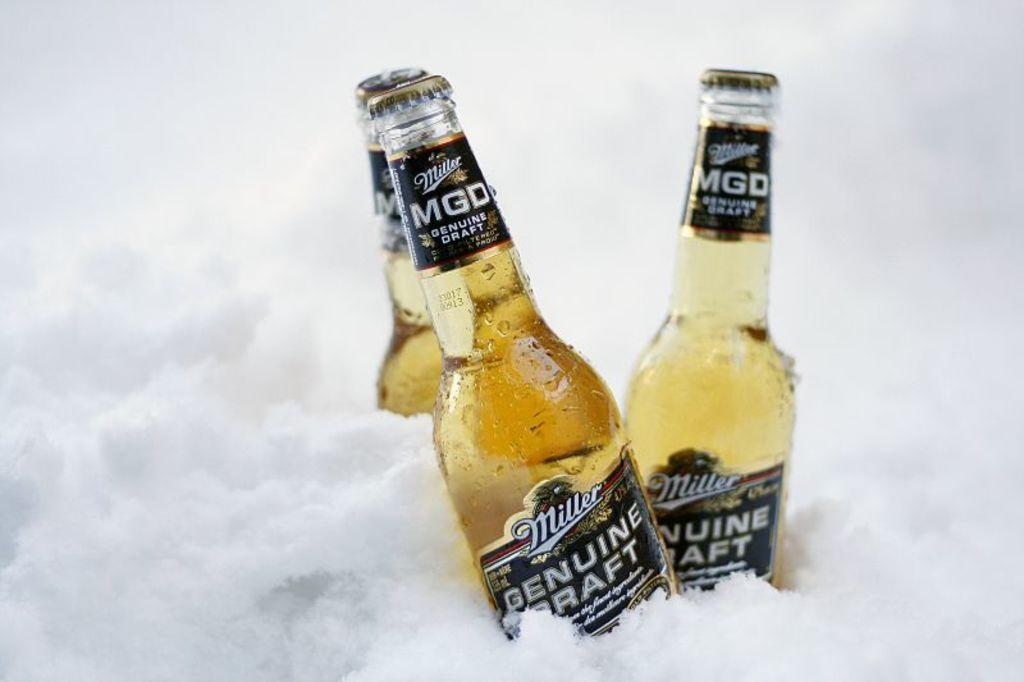Provide a one-sentence caption for the provided image. Two bottles of Miller Genuine Draft inside some crushed ice. 